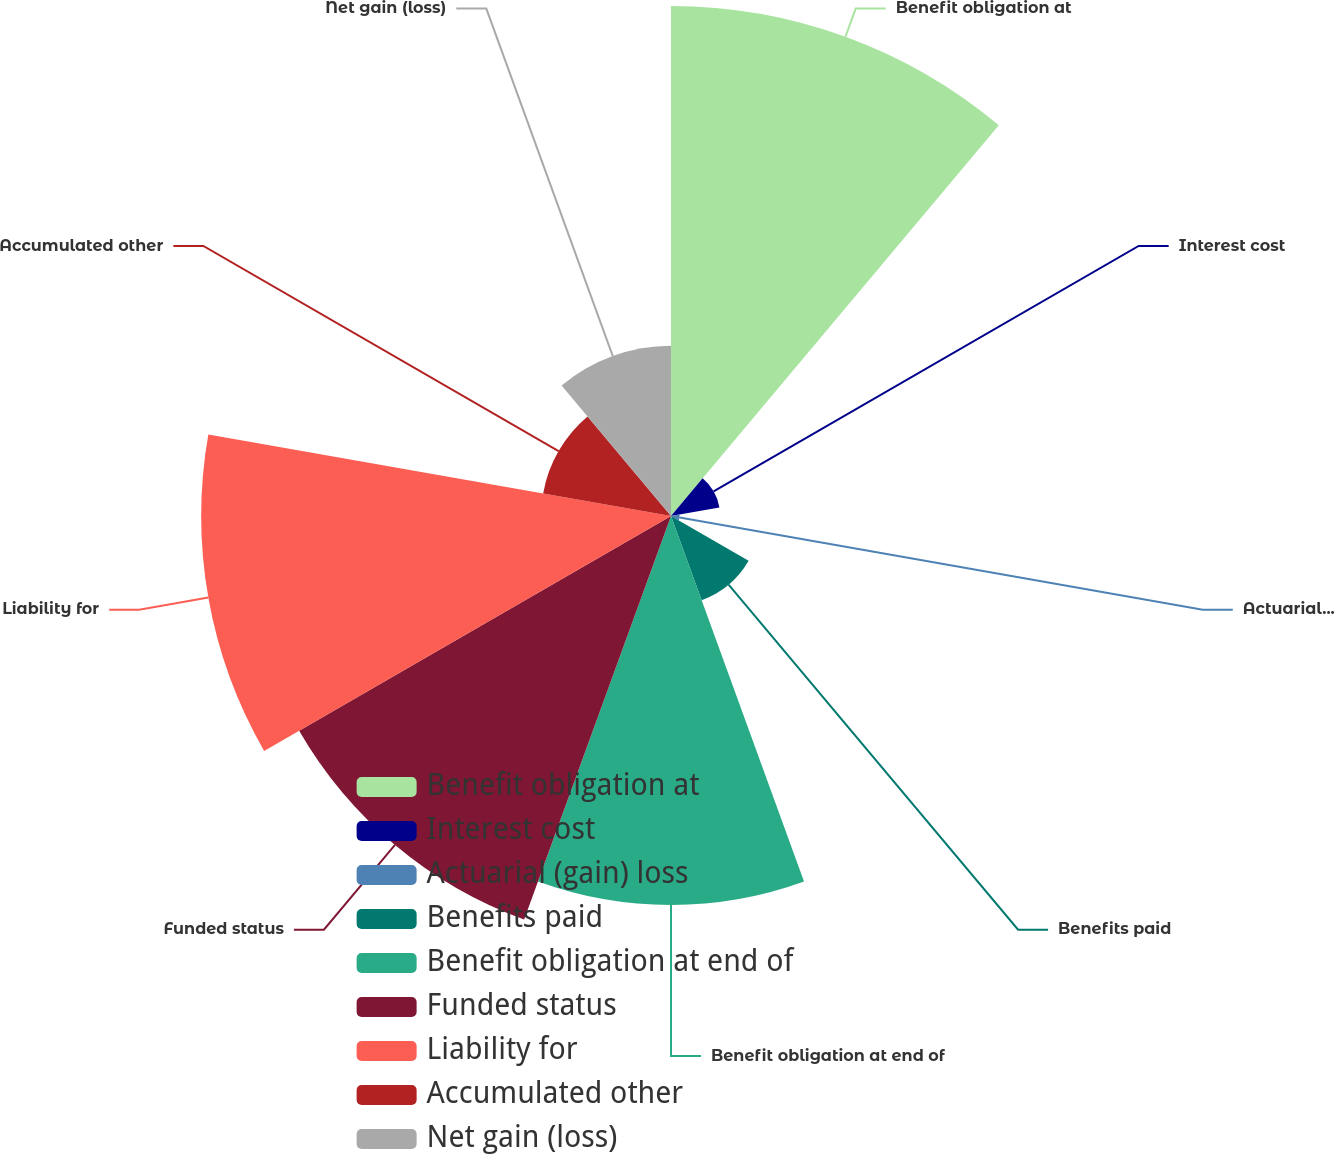Convert chart to OTSL. <chart><loc_0><loc_0><loc_500><loc_500><pie_chart><fcel>Benefit obligation at<fcel>Interest cost<fcel>Actuarial (gain) loss<fcel>Benefits paid<fcel>Benefit obligation at end of<fcel>Funded status<fcel>Liability for<fcel>Accumulated other<fcel>Net gain (loss)<nl><fcel>22.71%<fcel>2.19%<fcel>0.39%<fcel>3.99%<fcel>17.32%<fcel>19.12%<fcel>20.92%<fcel>5.78%<fcel>7.58%<nl></chart> 